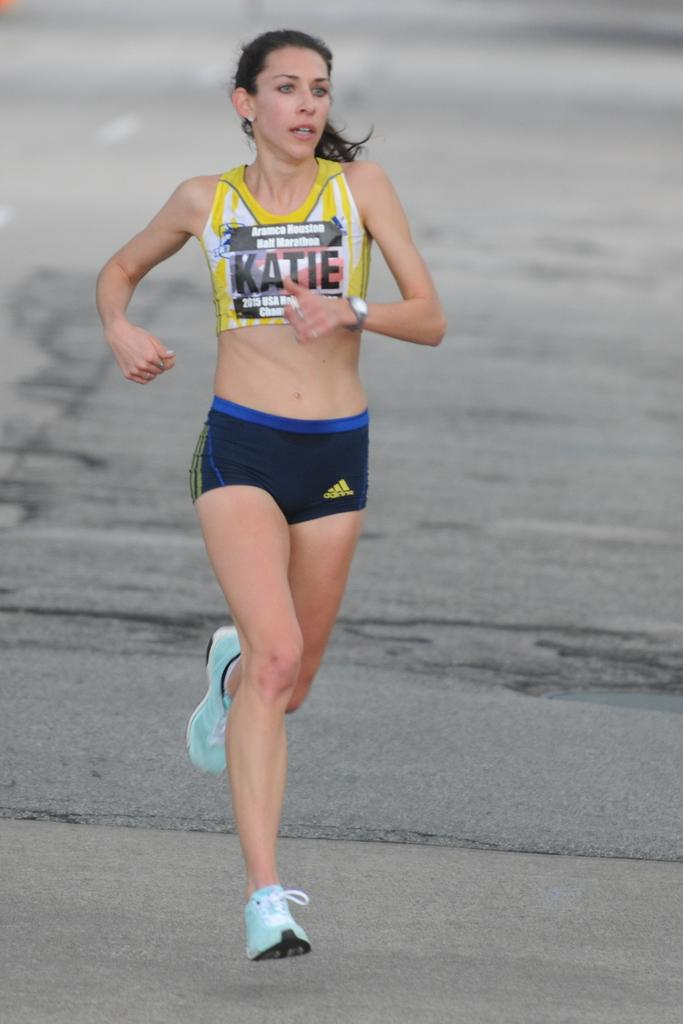<image>
Provide a brief description of the given image. A runner in the Aramco Houston Half Marathon has the name Katie on her vest. 